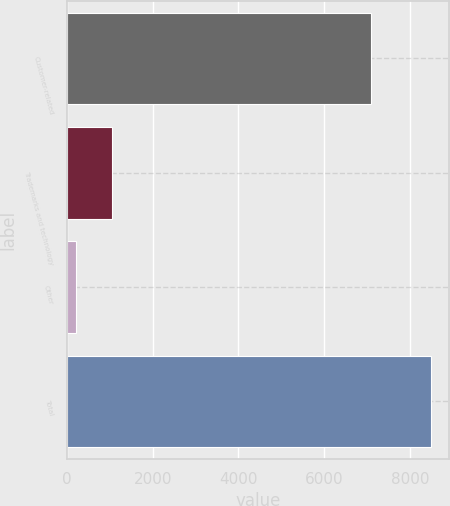Convert chart. <chart><loc_0><loc_0><loc_500><loc_500><bar_chart><fcel>Customer-related<fcel>Trademarks and technology<fcel>Other<fcel>Total<nl><fcel>7089<fcel>1044.2<fcel>217<fcel>8489<nl></chart> 